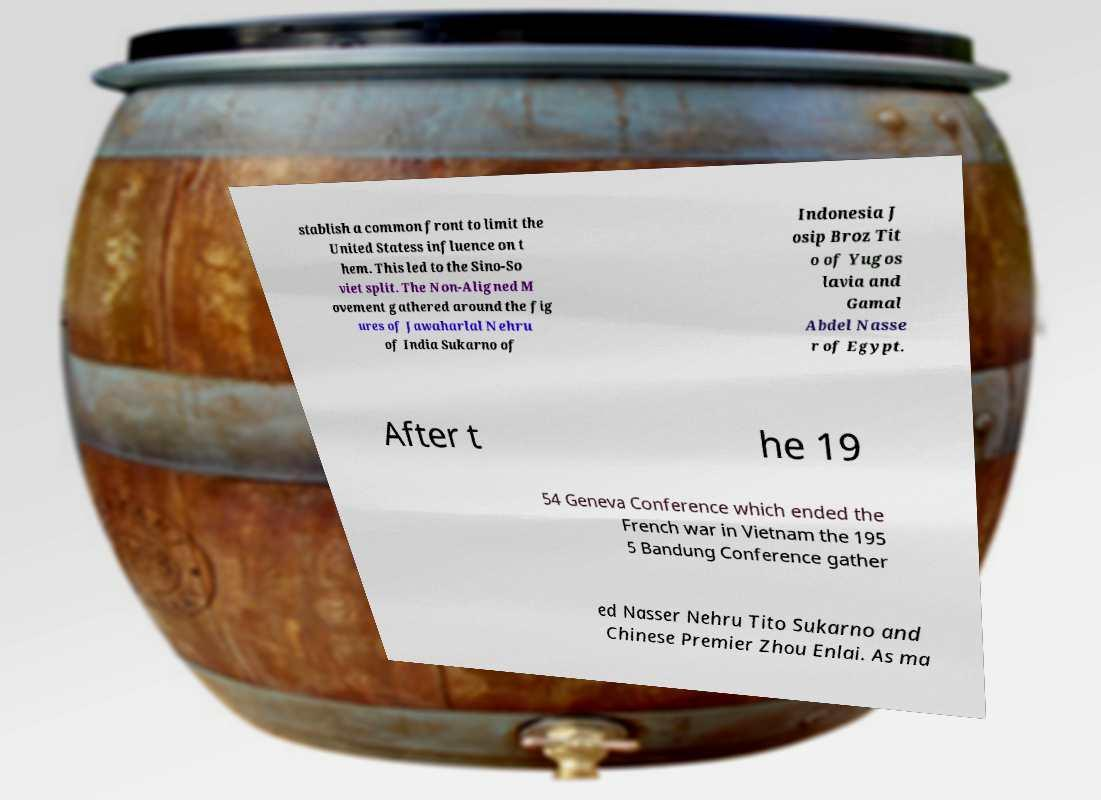Please read and relay the text visible in this image. What does it say? stablish a common front to limit the United Statess influence on t hem. This led to the Sino-So viet split. The Non-Aligned M ovement gathered around the fig ures of Jawaharlal Nehru of India Sukarno of Indonesia J osip Broz Tit o of Yugos lavia and Gamal Abdel Nasse r of Egypt. After t he 19 54 Geneva Conference which ended the French war in Vietnam the 195 5 Bandung Conference gather ed Nasser Nehru Tito Sukarno and Chinese Premier Zhou Enlai. As ma 